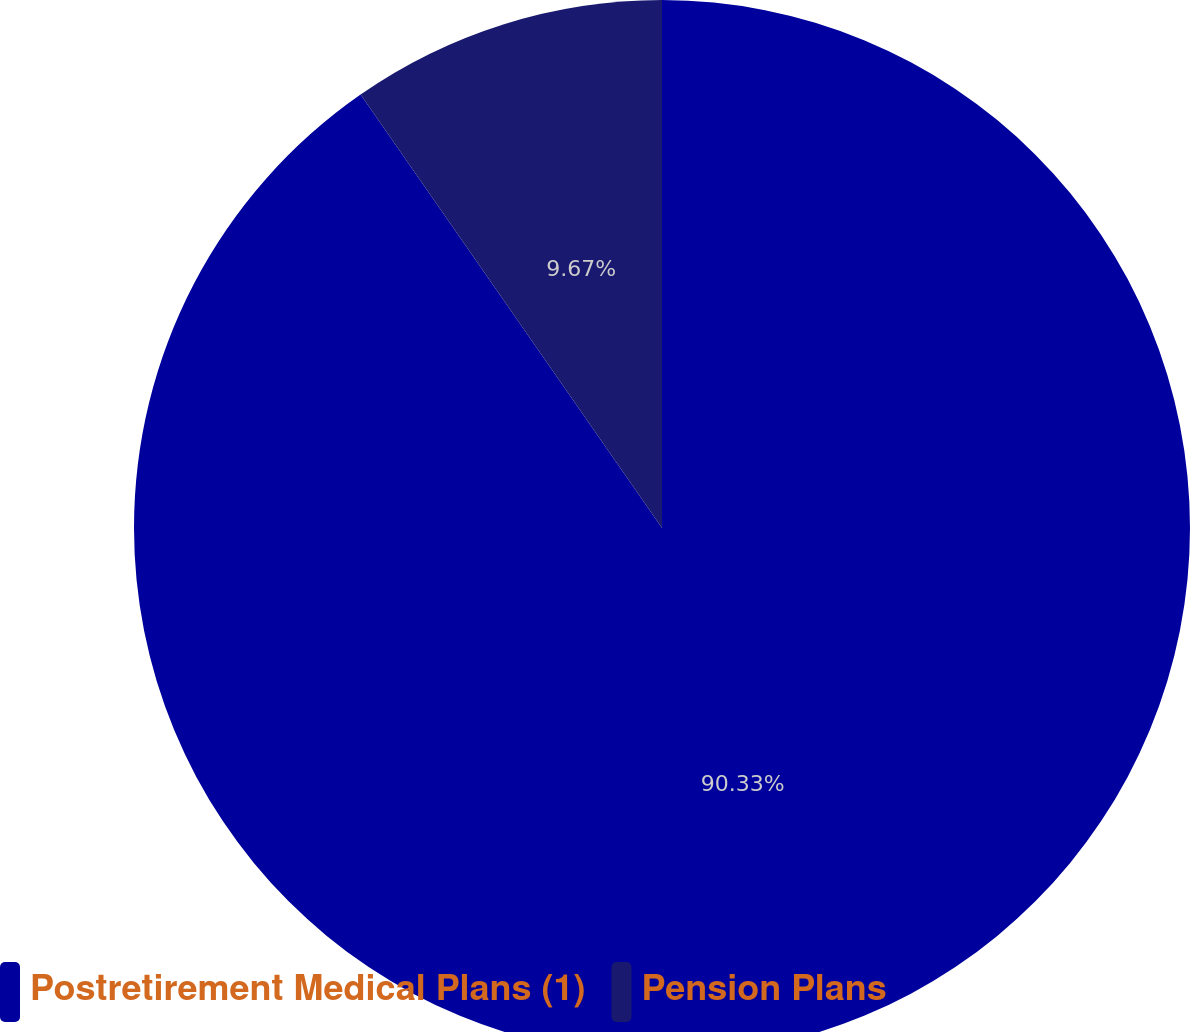<chart> <loc_0><loc_0><loc_500><loc_500><pie_chart><fcel>Postretirement Medical Plans (1)<fcel>Pension Plans<nl><fcel>90.33%<fcel>9.67%<nl></chart> 